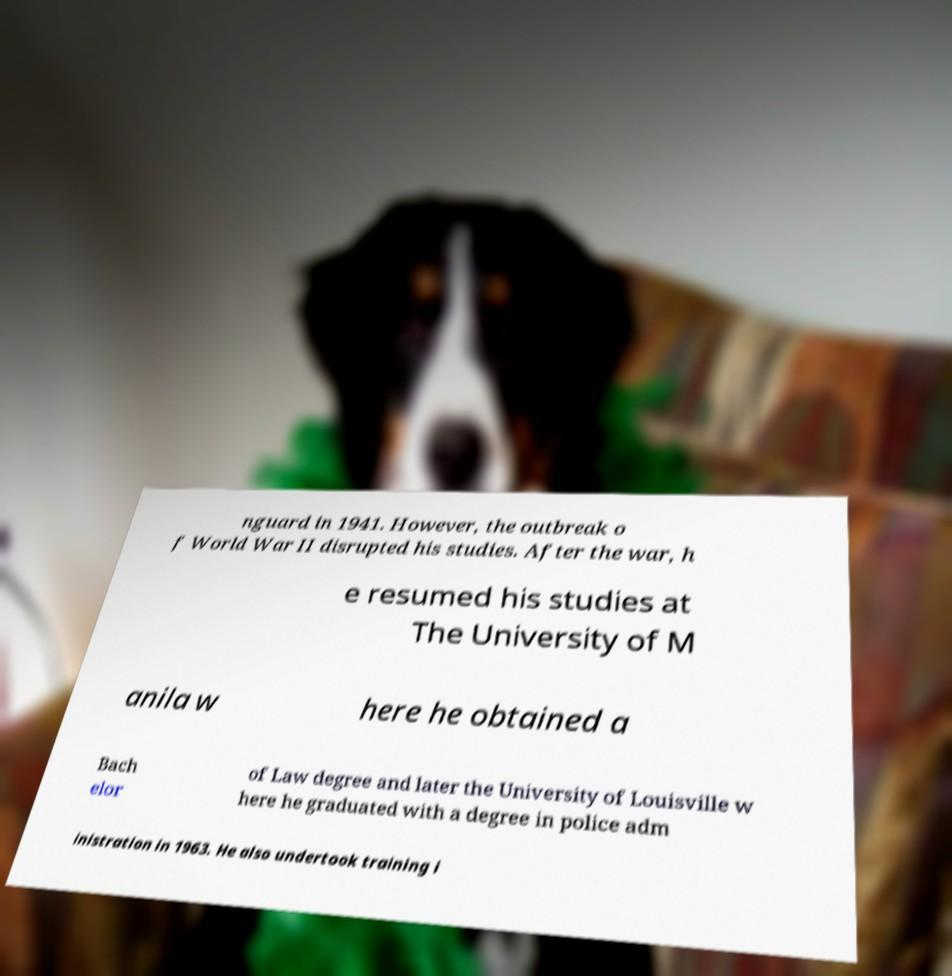For documentation purposes, I need the text within this image transcribed. Could you provide that? nguard in 1941. However, the outbreak o f World War II disrupted his studies. After the war, h e resumed his studies at The University of M anila w here he obtained a Bach elor of Law degree and later the University of Louisville w here he graduated with a degree in police adm inistration in 1963. He also undertook training i 